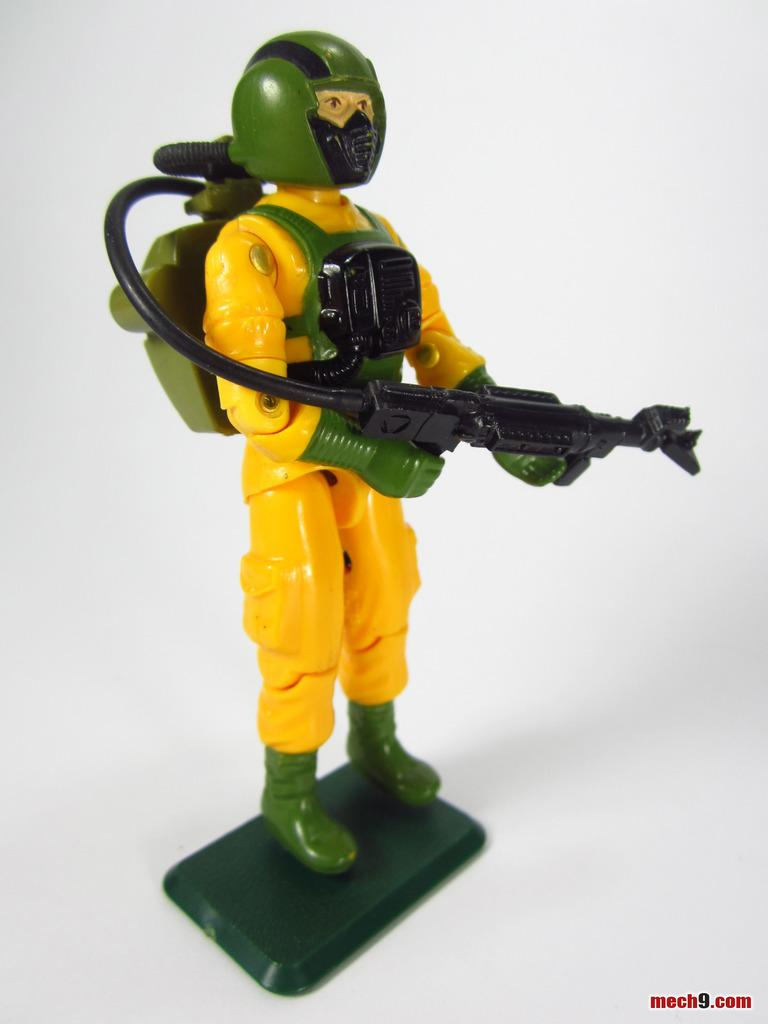What color is the toy in the image? The toy in the image is yellow. What accessory is the toy wearing? The toy has a green helmet. What additional object is associated with the toy? There is a gun-like object associated with the toy. What color is the background of the image? The background of the image is white. What type of zinc is present in the image? There is no zinc present in the image. How does the toy expand in the image? The toy does not expand in the image; it is a static object. 